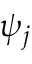Convert formula to latex. <formula><loc_0><loc_0><loc_500><loc_500>\psi _ { j }</formula> 